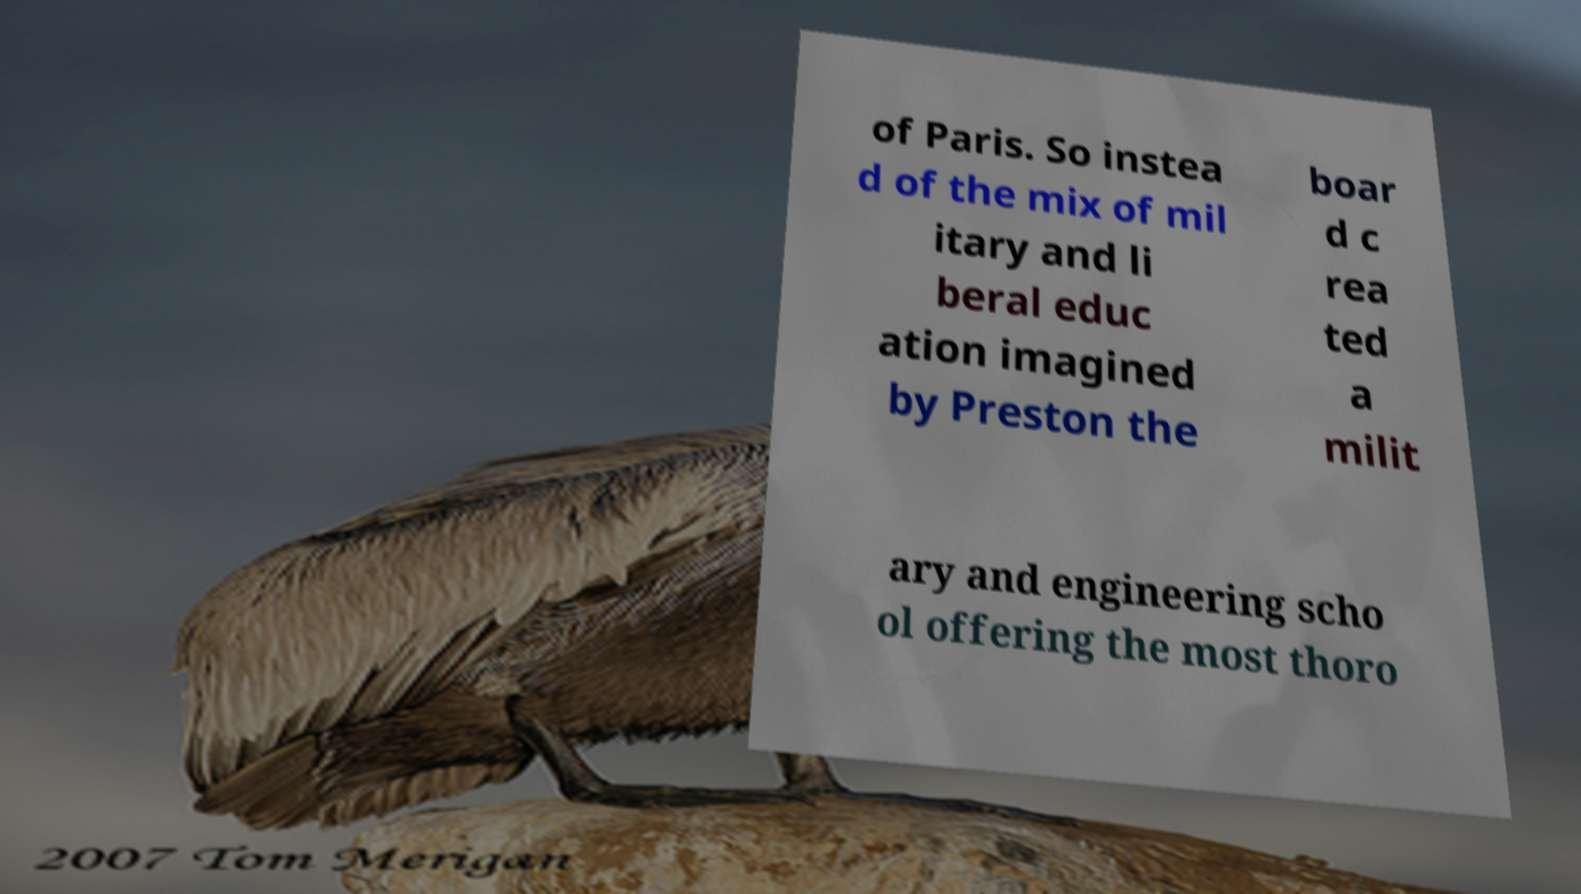Could you assist in decoding the text presented in this image and type it out clearly? of Paris. So instea d of the mix of mil itary and li beral educ ation imagined by Preston the boar d c rea ted a milit ary and engineering scho ol offering the most thoro 